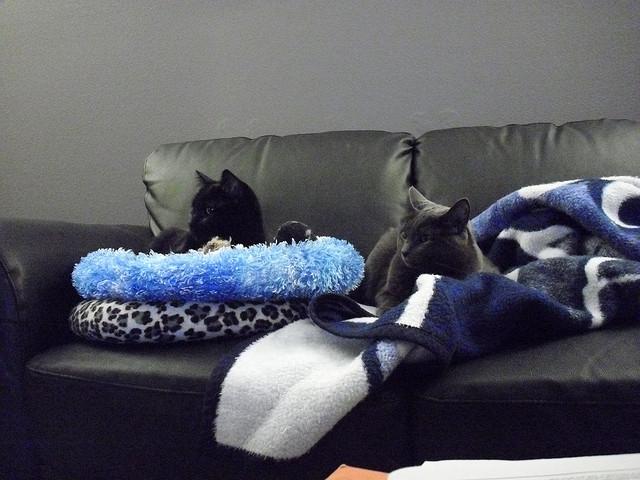Are these cats spoiled?
Keep it brief. Yes. Are the cats angry or content?
Short answer required. Content. Are the cats the same color?
Short answer required. No. 